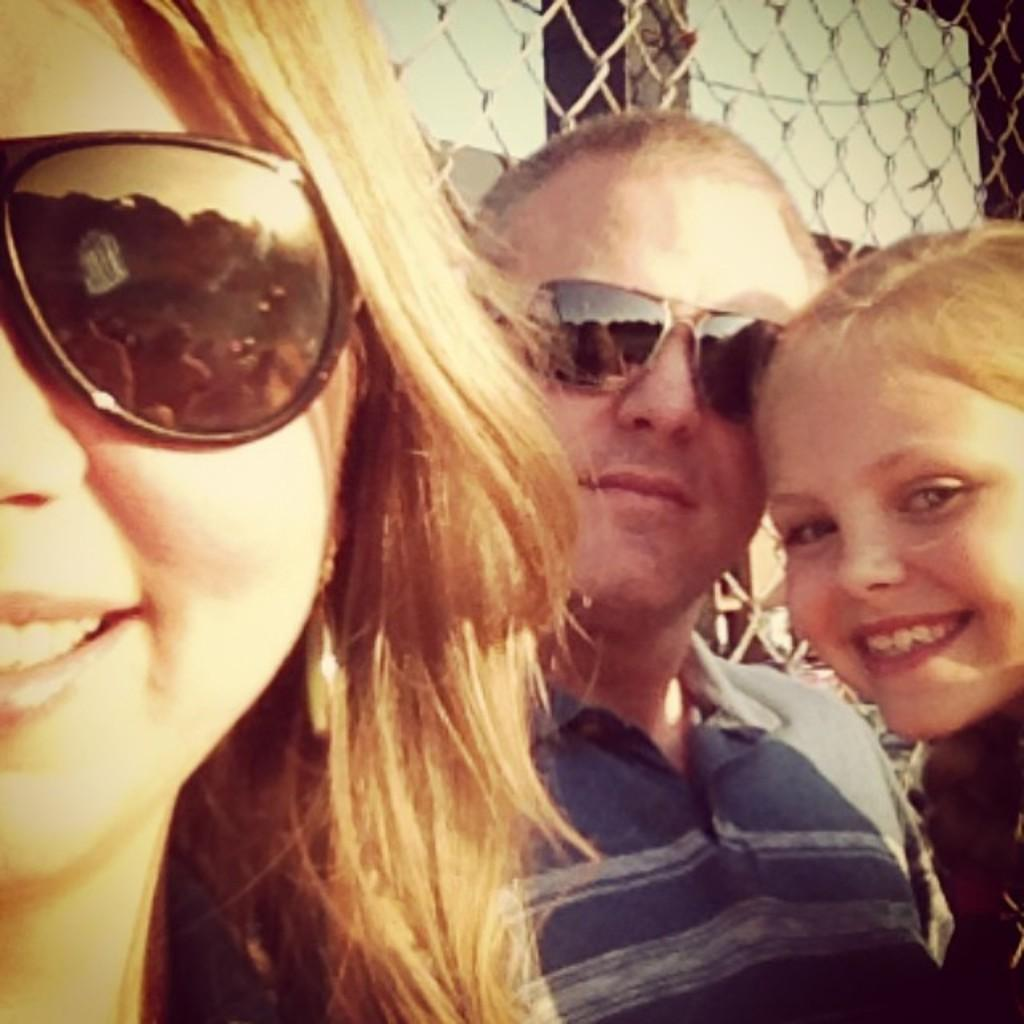How many people are in the image? There are persons in the image, but the exact number is not specified. What can be seen in the background of the image? There is a fence and an iron object in the background of the image. Are there any other objects visible in the background? Yes, there are other objects in the background of the image. What type of jewel is the robin holding in the image? There is no robin or jewel present in the image. How many geese are visible in the image? There are no geese present in the image. 